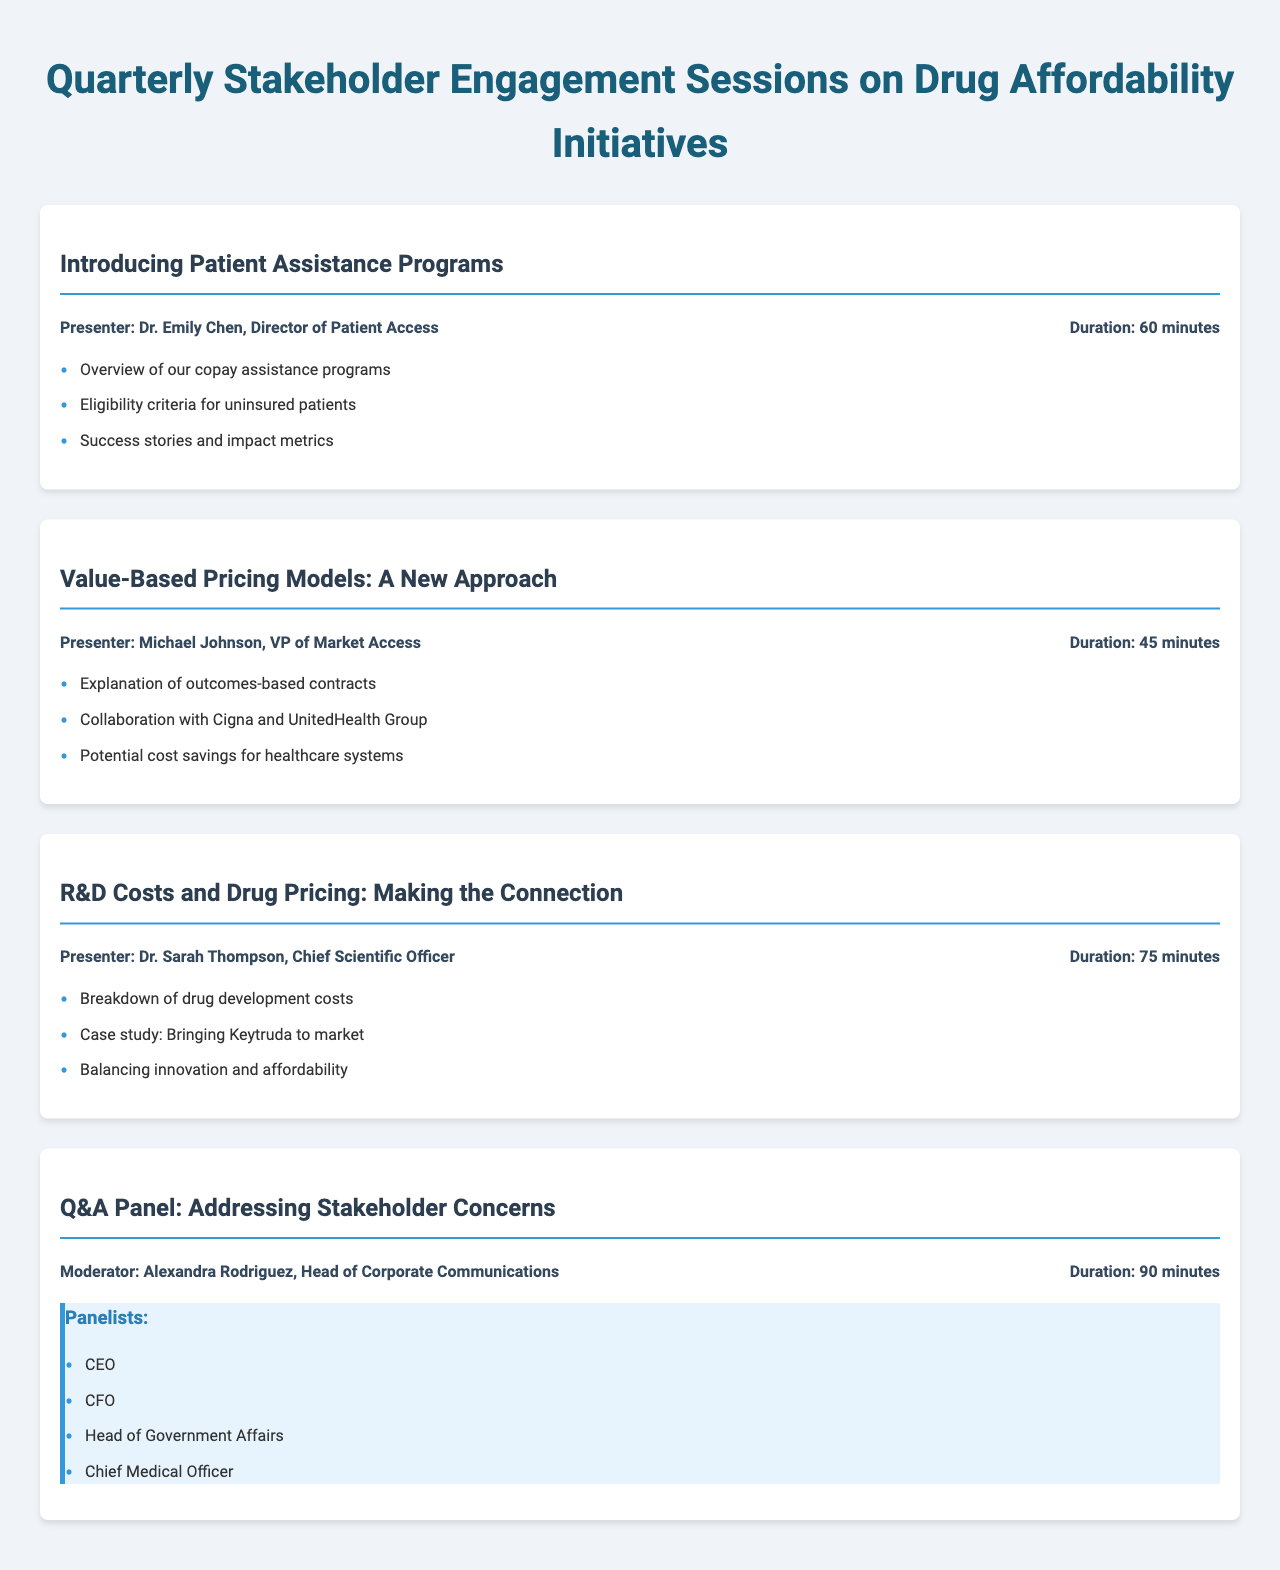What is the title of the first session? The title of the first session is specifically mentioned in the document as "Introducing Patient Assistance Programs."
Answer: Introducing Patient Assistance Programs Who is the presenter of the session on R&D Costs and Drug Pricing? The presenter for the R&D Costs and Drug Pricing session is listed as Dr. Sarah Thompson.
Answer: Dr. Sarah Thompson How long is the Q&A Panel session? The duration of the Q&A Panel session is provided in the document as 90 minutes.
Answer: 90 minutes What type of pricing models will be discussed in the second session? The second session focuses on "Value-Based Pricing Models," indicating a specific type of pricing model.
Answer: Value-Based Pricing Models Which organization collaborated with the Value-Based Pricing Models session? The document specifies collaboration with Cigna and UnitedHealth Group for this session.
Answer: Cigna and UnitedHealth Group What is a key point mentioned in the first session? The document lists key points for each session, such as "Overview of our copay assistance programs" for the first session.
Answer: Overview of our copay assistance programs Who is moderating the Q&A Panel? The moderator for the Q&A Panel, as indicated in the document, is Alexandra Rodriguez.
Answer: Alexandra Rodriguez What is a focus area of the third session? The third session centers on the connection between "R&D Costs and Drug Pricing," as noted in the key points.
Answer: R&D Costs and Drug Pricing What role does Michael Johnson hold? The document identifies that Michael Johnson is the VP of Market Access.
Answer: VP of Market Access 